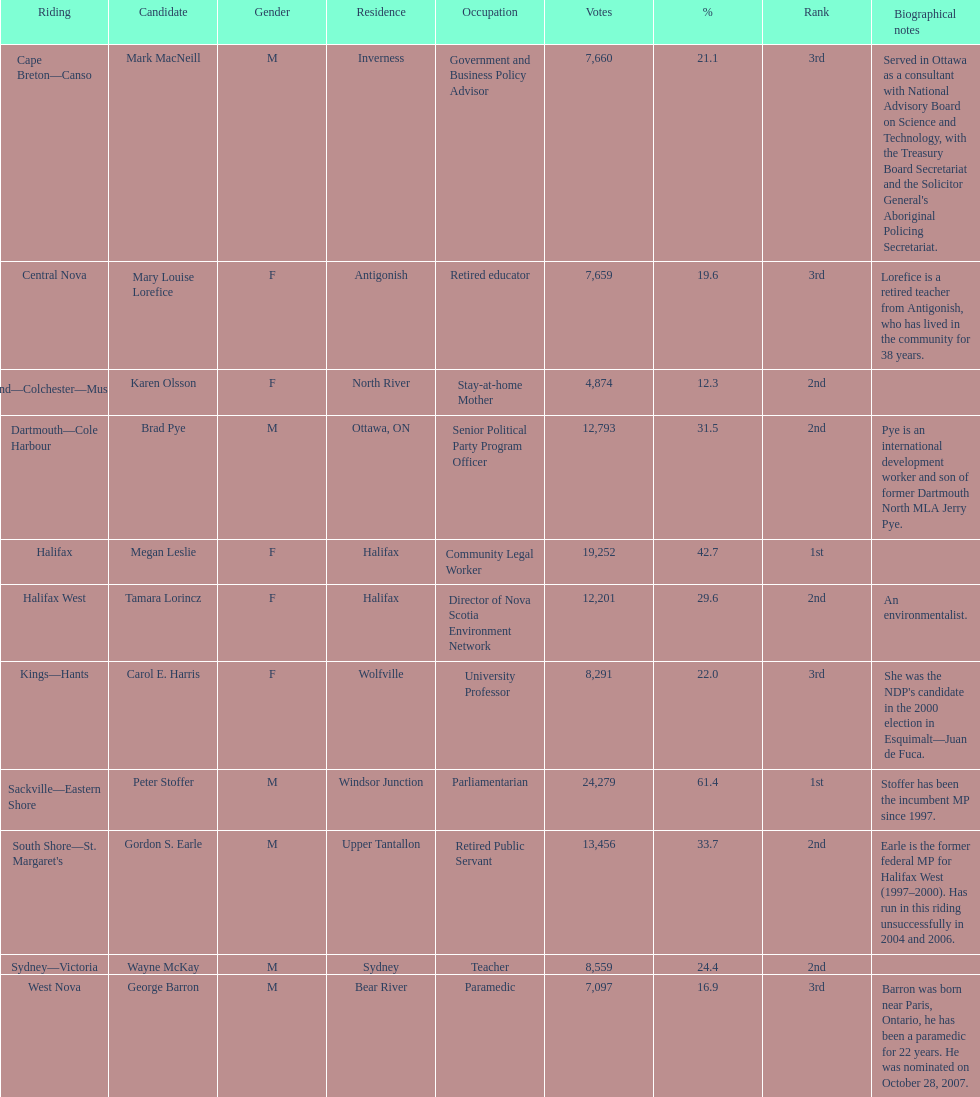What is the complete number of candidates? 11. 